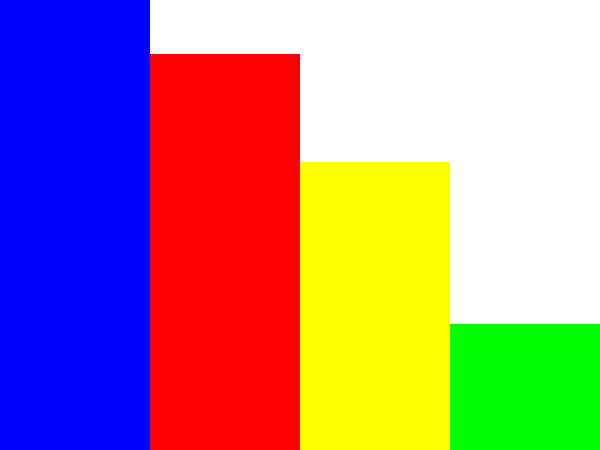Based on the bar graph showing the local election results in Chipping Barnet, what is the difference in votes between the Conservative and Labour parties? To find the difference in votes between the Conservative and Labour parties, we need to:

1. Identify the number of votes for the Conservative party:
   From the graph, we can see that the Conservative bar reaches approximately 12,500 votes.

2. Identify the number of votes for the Labour party:
   The Labour bar reaches approximately 11,000 votes.

3. Calculate the difference:
   $12,500 - 11,000 = 1,500$

Therefore, the difference in votes between the Conservative and Labour parties is 1,500 votes.
Answer: 1,500 votes 